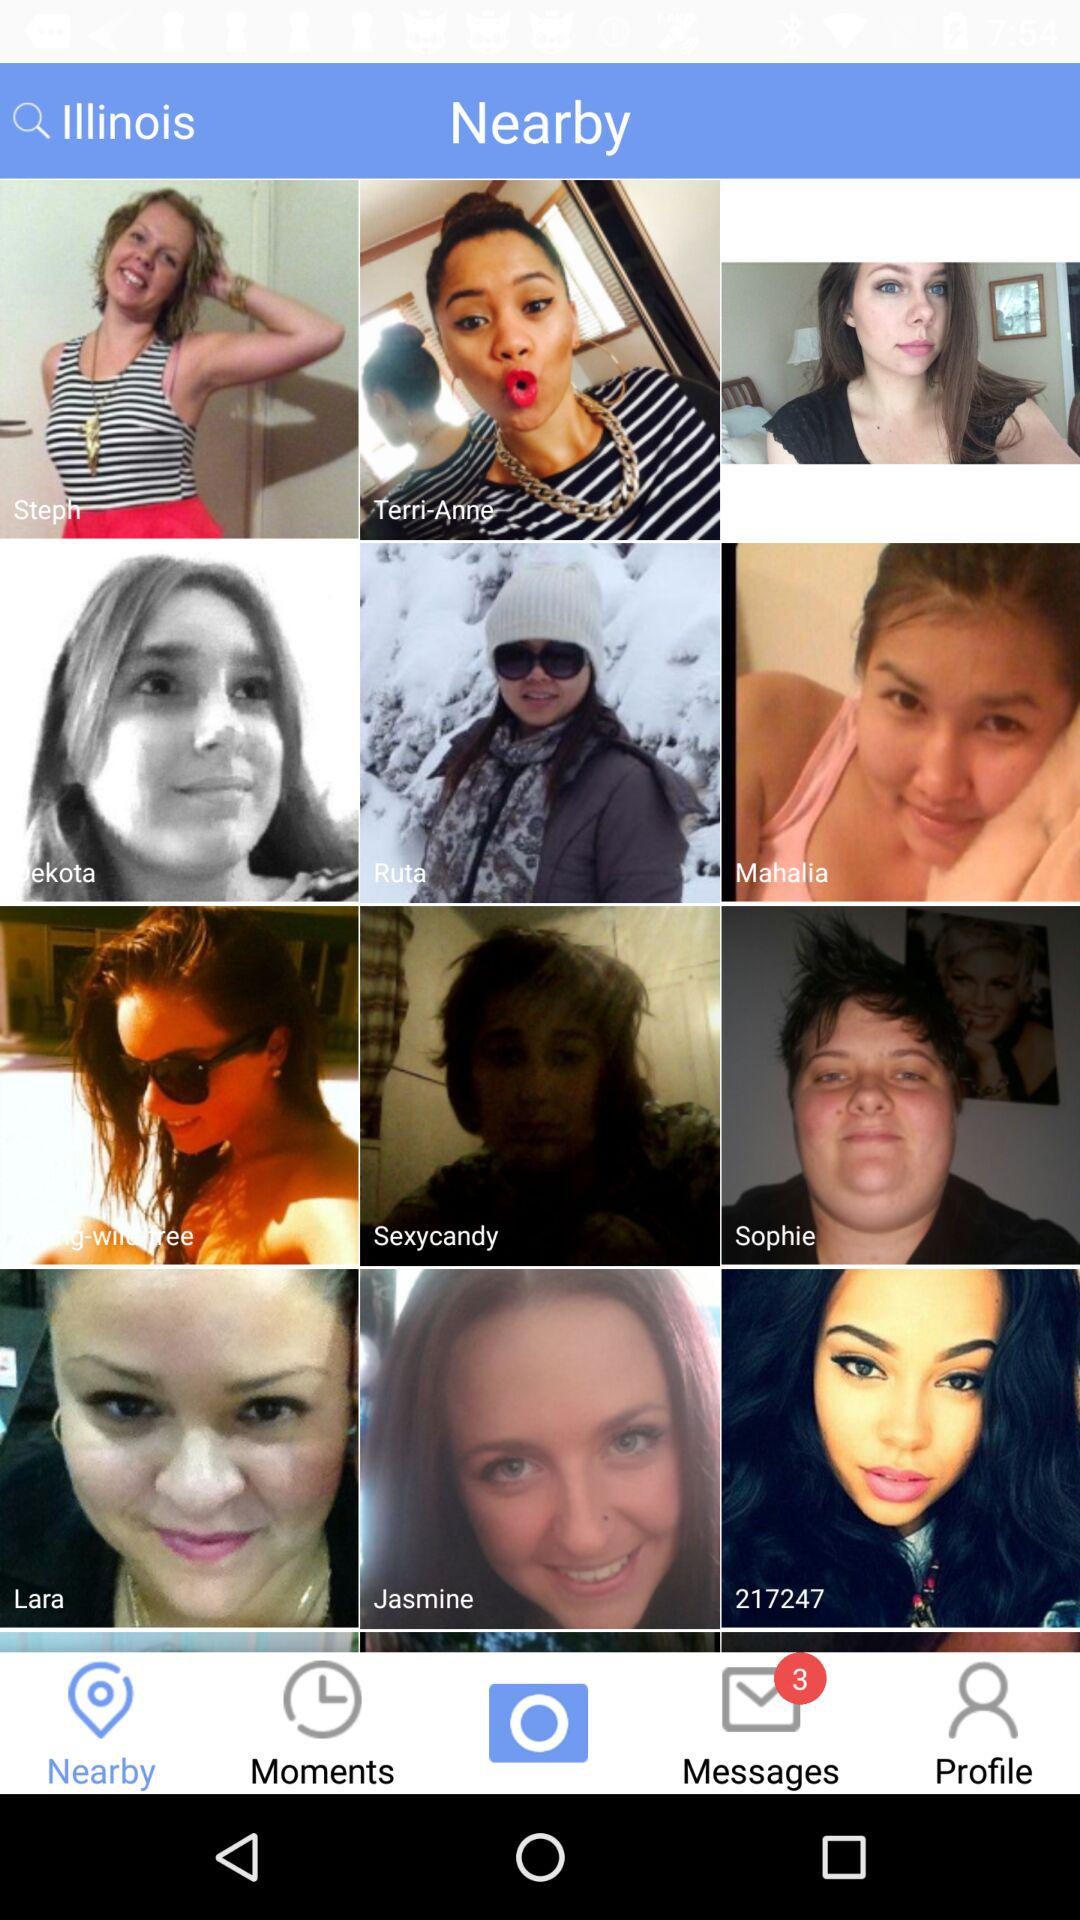What is the total number of unread messages? The total number of unread messages is 3. 